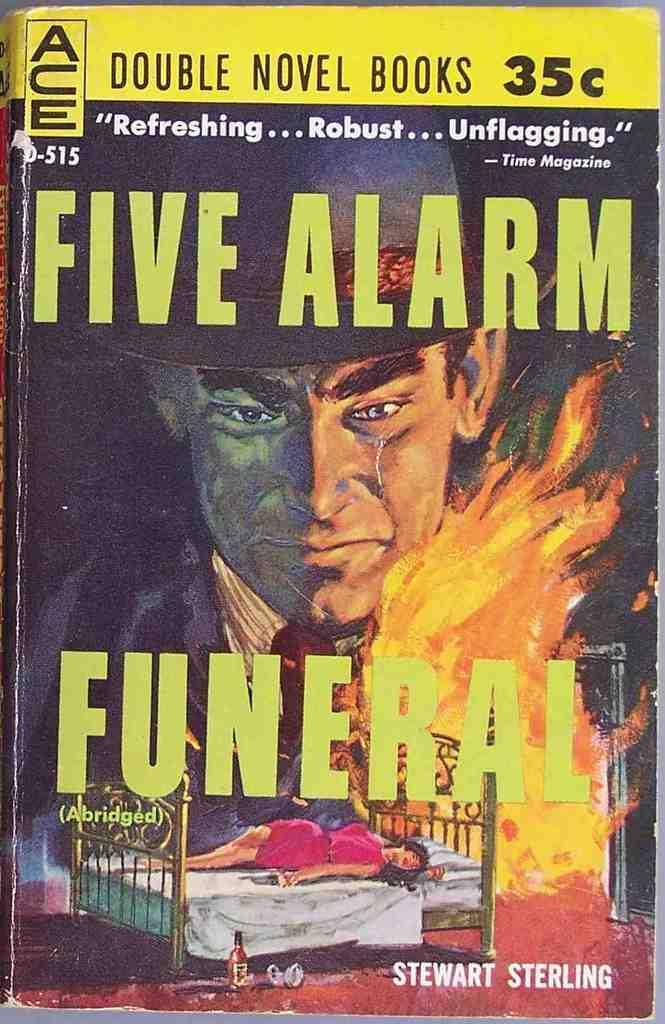<image>
Provide a brief description of the given image. A man is looking down at a woman, laying on a bed in front of a fire, on the cover of a graphic novel titled Five Alarm Funeral. 